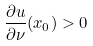Convert formula to latex. <formula><loc_0><loc_0><loc_500><loc_500>\frac { \partial u } { \partial \nu } ( x _ { 0 } ) > 0</formula> 